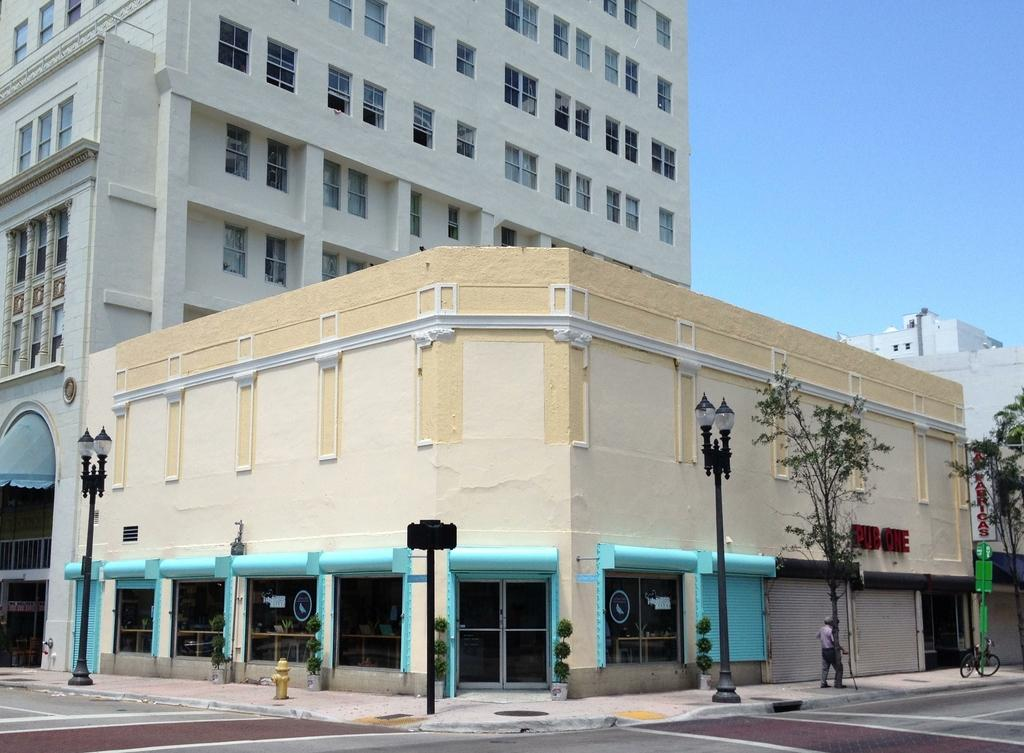What type of path is visible in the image? There is a footpath in the image. What other feature can be seen alongside the footpath? There is a road in the image. What object is present near the footpath and road? There is a hydrant in the image. Can you describe the person in the image? There is a person in the image. What mode of transportation is visible in the image? There is a bicycle in the image. What type of structures are present in the image? There are buildings with windows in the image. What type of objects can be seen in the image? There are poles and some objects in the image. What type of vegetation is present in the image? There are plants in the image. What architectural feature can be seen on the buildings? There are shutters in the image. What can be seen in the background of the image? The sky is visible in the background of the image. What type of skin is visible on the goose in the image? There is no goose present in the image. What event is taking place in the image related to the birth of a child? There is no event related to the birth of a child depicted in the image. 